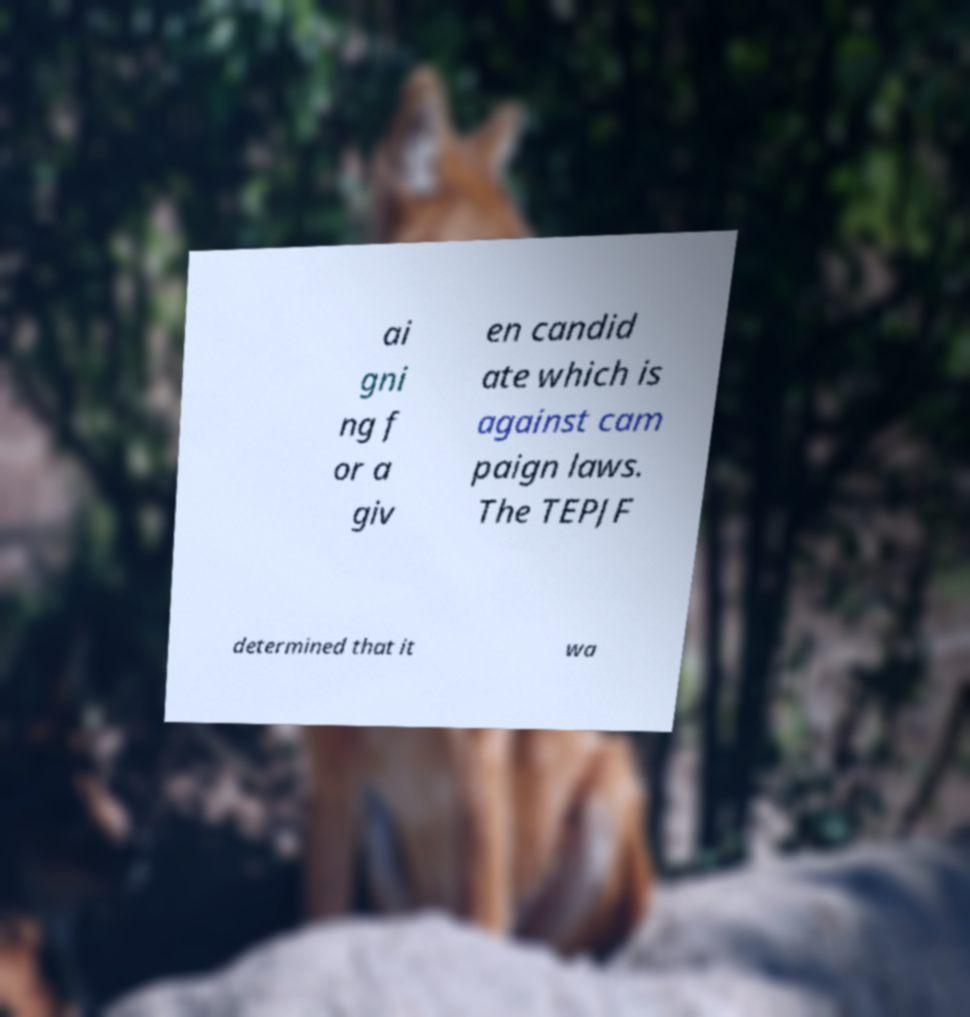Could you assist in decoding the text presented in this image and type it out clearly? ai gni ng f or a giv en candid ate which is against cam paign laws. The TEPJF determined that it wa 